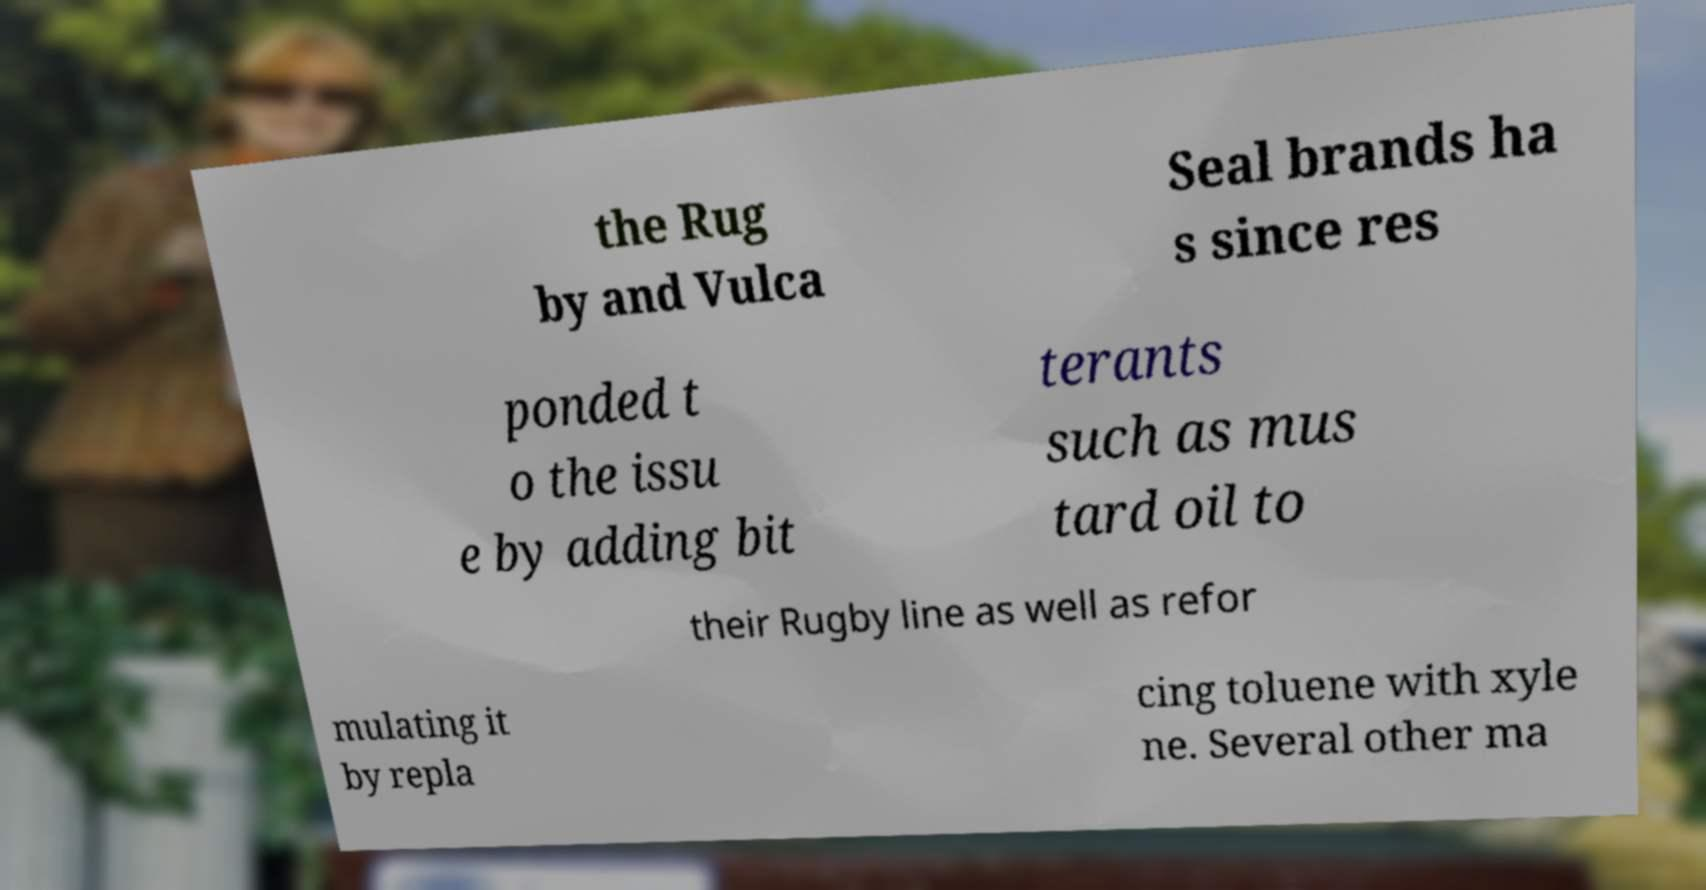Could you assist in decoding the text presented in this image and type it out clearly? the Rug by and Vulca Seal brands ha s since res ponded t o the issu e by adding bit terants such as mus tard oil to their Rugby line as well as refor mulating it by repla cing toluene with xyle ne. Several other ma 